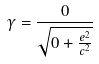Convert formula to latex. <formula><loc_0><loc_0><loc_500><loc_500>\gamma = \frac { 0 } { \sqrt { 0 + \frac { e ^ { 2 } } { c ^ { 2 } } } }</formula> 